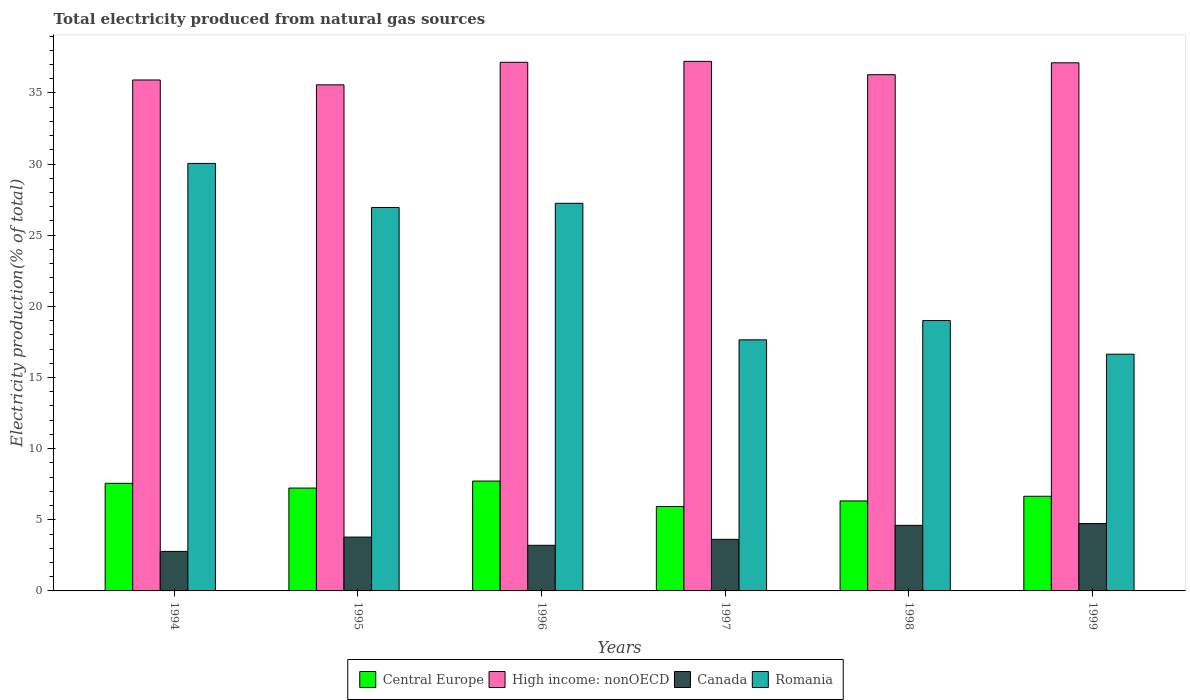How many groups of bars are there?
Keep it short and to the point. 6. How many bars are there on the 3rd tick from the left?
Your response must be concise. 4. What is the label of the 3rd group of bars from the left?
Make the answer very short. 1996. In how many cases, is the number of bars for a given year not equal to the number of legend labels?
Ensure brevity in your answer.  0. What is the total electricity produced in Romania in 1995?
Make the answer very short. 26.95. Across all years, what is the maximum total electricity produced in Canada?
Your response must be concise. 4.73. Across all years, what is the minimum total electricity produced in Romania?
Ensure brevity in your answer.  16.64. In which year was the total electricity produced in Romania maximum?
Your answer should be very brief. 1994. What is the total total electricity produced in Central Europe in the graph?
Ensure brevity in your answer.  41.42. What is the difference between the total electricity produced in Canada in 1998 and that in 1999?
Your response must be concise. -0.13. What is the difference between the total electricity produced in Central Europe in 1996 and the total electricity produced in Canada in 1999?
Your response must be concise. 2.99. What is the average total electricity produced in High income: nonOECD per year?
Offer a very short reply. 36.54. In the year 1994, what is the difference between the total electricity produced in High income: nonOECD and total electricity produced in Canada?
Your response must be concise. 33.13. What is the ratio of the total electricity produced in Canada in 1995 to that in 1999?
Your answer should be very brief. 0.8. Is the difference between the total electricity produced in High income: nonOECD in 1994 and 1998 greater than the difference between the total electricity produced in Canada in 1994 and 1998?
Your answer should be compact. Yes. What is the difference between the highest and the second highest total electricity produced in Central Europe?
Make the answer very short. 0.16. What is the difference between the highest and the lowest total electricity produced in Romania?
Keep it short and to the point. 13.41. Is the sum of the total electricity produced in Canada in 1996 and 1997 greater than the maximum total electricity produced in Romania across all years?
Offer a very short reply. No. What does the 1st bar from the left in 1995 represents?
Ensure brevity in your answer.  Central Europe. What does the 3rd bar from the right in 1996 represents?
Your answer should be compact. High income: nonOECD. How many bars are there?
Your answer should be compact. 24. Are all the bars in the graph horizontal?
Offer a very short reply. No. What is the difference between two consecutive major ticks on the Y-axis?
Provide a succinct answer. 5. How many legend labels are there?
Provide a succinct answer. 4. How are the legend labels stacked?
Your answer should be very brief. Horizontal. What is the title of the graph?
Provide a succinct answer. Total electricity produced from natural gas sources. Does "Morocco" appear as one of the legend labels in the graph?
Offer a very short reply. No. What is the Electricity production(% of total) in Central Europe in 1994?
Ensure brevity in your answer.  7.56. What is the Electricity production(% of total) of High income: nonOECD in 1994?
Ensure brevity in your answer.  35.91. What is the Electricity production(% of total) of Canada in 1994?
Offer a terse response. 2.78. What is the Electricity production(% of total) of Romania in 1994?
Make the answer very short. 30.05. What is the Electricity production(% of total) in Central Europe in 1995?
Keep it short and to the point. 7.23. What is the Electricity production(% of total) of High income: nonOECD in 1995?
Provide a succinct answer. 35.57. What is the Electricity production(% of total) in Canada in 1995?
Ensure brevity in your answer.  3.78. What is the Electricity production(% of total) of Romania in 1995?
Provide a succinct answer. 26.95. What is the Electricity production(% of total) of Central Europe in 1996?
Give a very brief answer. 7.72. What is the Electricity production(% of total) in High income: nonOECD in 1996?
Keep it short and to the point. 37.15. What is the Electricity production(% of total) in Canada in 1996?
Provide a succinct answer. 3.21. What is the Electricity production(% of total) of Romania in 1996?
Offer a terse response. 27.24. What is the Electricity production(% of total) in Central Europe in 1997?
Your answer should be very brief. 5.93. What is the Electricity production(% of total) in High income: nonOECD in 1997?
Your answer should be compact. 37.22. What is the Electricity production(% of total) in Canada in 1997?
Keep it short and to the point. 3.63. What is the Electricity production(% of total) in Romania in 1997?
Provide a succinct answer. 17.65. What is the Electricity production(% of total) of Central Europe in 1998?
Give a very brief answer. 6.32. What is the Electricity production(% of total) of High income: nonOECD in 1998?
Offer a very short reply. 36.28. What is the Electricity production(% of total) in Canada in 1998?
Provide a succinct answer. 4.61. What is the Electricity production(% of total) of Romania in 1998?
Provide a succinct answer. 19. What is the Electricity production(% of total) of Central Europe in 1999?
Your answer should be very brief. 6.65. What is the Electricity production(% of total) of High income: nonOECD in 1999?
Your response must be concise. 37.12. What is the Electricity production(% of total) of Canada in 1999?
Offer a terse response. 4.73. What is the Electricity production(% of total) in Romania in 1999?
Ensure brevity in your answer.  16.64. Across all years, what is the maximum Electricity production(% of total) of Central Europe?
Make the answer very short. 7.72. Across all years, what is the maximum Electricity production(% of total) in High income: nonOECD?
Offer a very short reply. 37.22. Across all years, what is the maximum Electricity production(% of total) of Canada?
Keep it short and to the point. 4.73. Across all years, what is the maximum Electricity production(% of total) in Romania?
Make the answer very short. 30.05. Across all years, what is the minimum Electricity production(% of total) of Central Europe?
Your answer should be compact. 5.93. Across all years, what is the minimum Electricity production(% of total) of High income: nonOECD?
Your response must be concise. 35.57. Across all years, what is the minimum Electricity production(% of total) of Canada?
Provide a succinct answer. 2.78. Across all years, what is the minimum Electricity production(% of total) of Romania?
Your answer should be very brief. 16.64. What is the total Electricity production(% of total) in Central Europe in the graph?
Provide a short and direct response. 41.42. What is the total Electricity production(% of total) of High income: nonOECD in the graph?
Ensure brevity in your answer.  219.25. What is the total Electricity production(% of total) in Canada in the graph?
Your response must be concise. 22.74. What is the total Electricity production(% of total) in Romania in the graph?
Make the answer very short. 137.52. What is the difference between the Electricity production(% of total) of Central Europe in 1994 and that in 1995?
Your answer should be very brief. 0.33. What is the difference between the Electricity production(% of total) of High income: nonOECD in 1994 and that in 1995?
Offer a very short reply. 0.34. What is the difference between the Electricity production(% of total) in Canada in 1994 and that in 1995?
Make the answer very short. -1.01. What is the difference between the Electricity production(% of total) in Romania in 1994 and that in 1995?
Ensure brevity in your answer.  3.1. What is the difference between the Electricity production(% of total) in Central Europe in 1994 and that in 1996?
Your response must be concise. -0.16. What is the difference between the Electricity production(% of total) in High income: nonOECD in 1994 and that in 1996?
Provide a succinct answer. -1.24. What is the difference between the Electricity production(% of total) of Canada in 1994 and that in 1996?
Offer a very short reply. -0.43. What is the difference between the Electricity production(% of total) of Romania in 1994 and that in 1996?
Make the answer very short. 2.8. What is the difference between the Electricity production(% of total) of Central Europe in 1994 and that in 1997?
Offer a terse response. 1.63. What is the difference between the Electricity production(% of total) in High income: nonOECD in 1994 and that in 1997?
Keep it short and to the point. -1.31. What is the difference between the Electricity production(% of total) in Canada in 1994 and that in 1997?
Make the answer very short. -0.85. What is the difference between the Electricity production(% of total) in Romania in 1994 and that in 1997?
Ensure brevity in your answer.  12.4. What is the difference between the Electricity production(% of total) of Central Europe in 1994 and that in 1998?
Ensure brevity in your answer.  1.24. What is the difference between the Electricity production(% of total) in High income: nonOECD in 1994 and that in 1998?
Provide a succinct answer. -0.37. What is the difference between the Electricity production(% of total) in Canada in 1994 and that in 1998?
Provide a succinct answer. -1.83. What is the difference between the Electricity production(% of total) in Romania in 1994 and that in 1998?
Provide a succinct answer. 11.04. What is the difference between the Electricity production(% of total) of Central Europe in 1994 and that in 1999?
Your answer should be very brief. 0.91. What is the difference between the Electricity production(% of total) of High income: nonOECD in 1994 and that in 1999?
Provide a short and direct response. -1.21. What is the difference between the Electricity production(% of total) of Canada in 1994 and that in 1999?
Keep it short and to the point. -1.96. What is the difference between the Electricity production(% of total) of Romania in 1994 and that in 1999?
Offer a very short reply. 13.41. What is the difference between the Electricity production(% of total) of Central Europe in 1995 and that in 1996?
Provide a short and direct response. -0.49. What is the difference between the Electricity production(% of total) of High income: nonOECD in 1995 and that in 1996?
Provide a short and direct response. -1.58. What is the difference between the Electricity production(% of total) of Canada in 1995 and that in 1996?
Your response must be concise. 0.58. What is the difference between the Electricity production(% of total) of Romania in 1995 and that in 1996?
Your answer should be very brief. -0.29. What is the difference between the Electricity production(% of total) in Central Europe in 1995 and that in 1997?
Provide a short and direct response. 1.29. What is the difference between the Electricity production(% of total) in High income: nonOECD in 1995 and that in 1997?
Your answer should be compact. -1.65. What is the difference between the Electricity production(% of total) of Canada in 1995 and that in 1997?
Ensure brevity in your answer.  0.16. What is the difference between the Electricity production(% of total) in Romania in 1995 and that in 1997?
Keep it short and to the point. 9.3. What is the difference between the Electricity production(% of total) in Central Europe in 1995 and that in 1998?
Your answer should be very brief. 0.91. What is the difference between the Electricity production(% of total) in High income: nonOECD in 1995 and that in 1998?
Ensure brevity in your answer.  -0.71. What is the difference between the Electricity production(% of total) of Canada in 1995 and that in 1998?
Ensure brevity in your answer.  -0.83. What is the difference between the Electricity production(% of total) of Romania in 1995 and that in 1998?
Give a very brief answer. 7.95. What is the difference between the Electricity production(% of total) of Central Europe in 1995 and that in 1999?
Offer a terse response. 0.58. What is the difference between the Electricity production(% of total) of High income: nonOECD in 1995 and that in 1999?
Your response must be concise. -1.55. What is the difference between the Electricity production(% of total) in Canada in 1995 and that in 1999?
Ensure brevity in your answer.  -0.95. What is the difference between the Electricity production(% of total) in Romania in 1995 and that in 1999?
Your response must be concise. 10.31. What is the difference between the Electricity production(% of total) of Central Europe in 1996 and that in 1997?
Make the answer very short. 1.79. What is the difference between the Electricity production(% of total) of High income: nonOECD in 1996 and that in 1997?
Offer a very short reply. -0.07. What is the difference between the Electricity production(% of total) of Canada in 1996 and that in 1997?
Provide a short and direct response. -0.42. What is the difference between the Electricity production(% of total) in Romania in 1996 and that in 1997?
Keep it short and to the point. 9.6. What is the difference between the Electricity production(% of total) of Central Europe in 1996 and that in 1998?
Ensure brevity in your answer.  1.4. What is the difference between the Electricity production(% of total) of High income: nonOECD in 1996 and that in 1998?
Offer a very short reply. 0.87. What is the difference between the Electricity production(% of total) of Canada in 1996 and that in 1998?
Provide a short and direct response. -1.4. What is the difference between the Electricity production(% of total) in Romania in 1996 and that in 1998?
Offer a terse response. 8.24. What is the difference between the Electricity production(% of total) of Central Europe in 1996 and that in 1999?
Make the answer very short. 1.07. What is the difference between the Electricity production(% of total) in High income: nonOECD in 1996 and that in 1999?
Offer a terse response. 0.04. What is the difference between the Electricity production(% of total) of Canada in 1996 and that in 1999?
Provide a short and direct response. -1.53. What is the difference between the Electricity production(% of total) of Romania in 1996 and that in 1999?
Give a very brief answer. 10.6. What is the difference between the Electricity production(% of total) in Central Europe in 1997 and that in 1998?
Keep it short and to the point. -0.39. What is the difference between the Electricity production(% of total) in High income: nonOECD in 1997 and that in 1998?
Offer a terse response. 0.94. What is the difference between the Electricity production(% of total) of Canada in 1997 and that in 1998?
Provide a succinct answer. -0.98. What is the difference between the Electricity production(% of total) of Romania in 1997 and that in 1998?
Your answer should be very brief. -1.36. What is the difference between the Electricity production(% of total) in Central Europe in 1997 and that in 1999?
Provide a succinct answer. -0.72. What is the difference between the Electricity production(% of total) of High income: nonOECD in 1997 and that in 1999?
Your answer should be very brief. 0.1. What is the difference between the Electricity production(% of total) in Canada in 1997 and that in 1999?
Provide a succinct answer. -1.11. What is the difference between the Electricity production(% of total) of Romania in 1997 and that in 1999?
Offer a very short reply. 1.01. What is the difference between the Electricity production(% of total) in Central Europe in 1998 and that in 1999?
Provide a succinct answer. -0.33. What is the difference between the Electricity production(% of total) of High income: nonOECD in 1998 and that in 1999?
Your response must be concise. -0.83. What is the difference between the Electricity production(% of total) in Canada in 1998 and that in 1999?
Your response must be concise. -0.12. What is the difference between the Electricity production(% of total) in Romania in 1998 and that in 1999?
Ensure brevity in your answer.  2.36. What is the difference between the Electricity production(% of total) in Central Europe in 1994 and the Electricity production(% of total) in High income: nonOECD in 1995?
Give a very brief answer. -28.01. What is the difference between the Electricity production(% of total) of Central Europe in 1994 and the Electricity production(% of total) of Canada in 1995?
Keep it short and to the point. 3.78. What is the difference between the Electricity production(% of total) of Central Europe in 1994 and the Electricity production(% of total) of Romania in 1995?
Your answer should be very brief. -19.39. What is the difference between the Electricity production(% of total) in High income: nonOECD in 1994 and the Electricity production(% of total) in Canada in 1995?
Make the answer very short. 32.13. What is the difference between the Electricity production(% of total) of High income: nonOECD in 1994 and the Electricity production(% of total) of Romania in 1995?
Give a very brief answer. 8.96. What is the difference between the Electricity production(% of total) in Canada in 1994 and the Electricity production(% of total) in Romania in 1995?
Your answer should be compact. -24.17. What is the difference between the Electricity production(% of total) in Central Europe in 1994 and the Electricity production(% of total) in High income: nonOECD in 1996?
Keep it short and to the point. -29.59. What is the difference between the Electricity production(% of total) in Central Europe in 1994 and the Electricity production(% of total) in Canada in 1996?
Provide a short and direct response. 4.36. What is the difference between the Electricity production(% of total) in Central Europe in 1994 and the Electricity production(% of total) in Romania in 1996?
Keep it short and to the point. -19.68. What is the difference between the Electricity production(% of total) in High income: nonOECD in 1994 and the Electricity production(% of total) in Canada in 1996?
Provide a short and direct response. 32.7. What is the difference between the Electricity production(% of total) in High income: nonOECD in 1994 and the Electricity production(% of total) in Romania in 1996?
Provide a succinct answer. 8.67. What is the difference between the Electricity production(% of total) of Canada in 1994 and the Electricity production(% of total) of Romania in 1996?
Provide a short and direct response. -24.46. What is the difference between the Electricity production(% of total) of Central Europe in 1994 and the Electricity production(% of total) of High income: nonOECD in 1997?
Keep it short and to the point. -29.66. What is the difference between the Electricity production(% of total) in Central Europe in 1994 and the Electricity production(% of total) in Canada in 1997?
Your answer should be very brief. 3.94. What is the difference between the Electricity production(% of total) of Central Europe in 1994 and the Electricity production(% of total) of Romania in 1997?
Your response must be concise. -10.08. What is the difference between the Electricity production(% of total) in High income: nonOECD in 1994 and the Electricity production(% of total) in Canada in 1997?
Make the answer very short. 32.28. What is the difference between the Electricity production(% of total) in High income: nonOECD in 1994 and the Electricity production(% of total) in Romania in 1997?
Offer a very short reply. 18.26. What is the difference between the Electricity production(% of total) of Canada in 1994 and the Electricity production(% of total) of Romania in 1997?
Ensure brevity in your answer.  -14.87. What is the difference between the Electricity production(% of total) of Central Europe in 1994 and the Electricity production(% of total) of High income: nonOECD in 1998?
Your response must be concise. -28.72. What is the difference between the Electricity production(% of total) of Central Europe in 1994 and the Electricity production(% of total) of Canada in 1998?
Keep it short and to the point. 2.95. What is the difference between the Electricity production(% of total) in Central Europe in 1994 and the Electricity production(% of total) in Romania in 1998?
Your answer should be compact. -11.44. What is the difference between the Electricity production(% of total) of High income: nonOECD in 1994 and the Electricity production(% of total) of Canada in 1998?
Provide a succinct answer. 31.3. What is the difference between the Electricity production(% of total) in High income: nonOECD in 1994 and the Electricity production(% of total) in Romania in 1998?
Your answer should be very brief. 16.91. What is the difference between the Electricity production(% of total) of Canada in 1994 and the Electricity production(% of total) of Romania in 1998?
Your answer should be compact. -16.22. What is the difference between the Electricity production(% of total) in Central Europe in 1994 and the Electricity production(% of total) in High income: nonOECD in 1999?
Your response must be concise. -29.55. What is the difference between the Electricity production(% of total) in Central Europe in 1994 and the Electricity production(% of total) in Canada in 1999?
Offer a very short reply. 2.83. What is the difference between the Electricity production(% of total) of Central Europe in 1994 and the Electricity production(% of total) of Romania in 1999?
Offer a terse response. -9.08. What is the difference between the Electricity production(% of total) of High income: nonOECD in 1994 and the Electricity production(% of total) of Canada in 1999?
Provide a succinct answer. 31.18. What is the difference between the Electricity production(% of total) of High income: nonOECD in 1994 and the Electricity production(% of total) of Romania in 1999?
Give a very brief answer. 19.27. What is the difference between the Electricity production(% of total) in Canada in 1994 and the Electricity production(% of total) in Romania in 1999?
Offer a terse response. -13.86. What is the difference between the Electricity production(% of total) in Central Europe in 1995 and the Electricity production(% of total) in High income: nonOECD in 1996?
Make the answer very short. -29.92. What is the difference between the Electricity production(% of total) in Central Europe in 1995 and the Electricity production(% of total) in Canada in 1996?
Give a very brief answer. 4.02. What is the difference between the Electricity production(% of total) in Central Europe in 1995 and the Electricity production(% of total) in Romania in 1996?
Your answer should be compact. -20.01. What is the difference between the Electricity production(% of total) in High income: nonOECD in 1995 and the Electricity production(% of total) in Canada in 1996?
Provide a succinct answer. 32.36. What is the difference between the Electricity production(% of total) of High income: nonOECD in 1995 and the Electricity production(% of total) of Romania in 1996?
Provide a succinct answer. 8.33. What is the difference between the Electricity production(% of total) of Canada in 1995 and the Electricity production(% of total) of Romania in 1996?
Your answer should be very brief. -23.46. What is the difference between the Electricity production(% of total) of Central Europe in 1995 and the Electricity production(% of total) of High income: nonOECD in 1997?
Provide a succinct answer. -29.99. What is the difference between the Electricity production(% of total) of Central Europe in 1995 and the Electricity production(% of total) of Canada in 1997?
Offer a terse response. 3.6. What is the difference between the Electricity production(% of total) of Central Europe in 1995 and the Electricity production(% of total) of Romania in 1997?
Provide a short and direct response. -10.42. What is the difference between the Electricity production(% of total) in High income: nonOECD in 1995 and the Electricity production(% of total) in Canada in 1997?
Give a very brief answer. 31.94. What is the difference between the Electricity production(% of total) of High income: nonOECD in 1995 and the Electricity production(% of total) of Romania in 1997?
Give a very brief answer. 17.92. What is the difference between the Electricity production(% of total) in Canada in 1995 and the Electricity production(% of total) in Romania in 1997?
Provide a short and direct response. -13.86. What is the difference between the Electricity production(% of total) in Central Europe in 1995 and the Electricity production(% of total) in High income: nonOECD in 1998?
Offer a terse response. -29.05. What is the difference between the Electricity production(% of total) of Central Europe in 1995 and the Electricity production(% of total) of Canada in 1998?
Your answer should be compact. 2.62. What is the difference between the Electricity production(% of total) in Central Europe in 1995 and the Electricity production(% of total) in Romania in 1998?
Your response must be concise. -11.77. What is the difference between the Electricity production(% of total) in High income: nonOECD in 1995 and the Electricity production(% of total) in Canada in 1998?
Your answer should be compact. 30.96. What is the difference between the Electricity production(% of total) of High income: nonOECD in 1995 and the Electricity production(% of total) of Romania in 1998?
Provide a short and direct response. 16.57. What is the difference between the Electricity production(% of total) of Canada in 1995 and the Electricity production(% of total) of Romania in 1998?
Your answer should be compact. -15.22. What is the difference between the Electricity production(% of total) in Central Europe in 1995 and the Electricity production(% of total) in High income: nonOECD in 1999?
Make the answer very short. -29.89. What is the difference between the Electricity production(% of total) of Central Europe in 1995 and the Electricity production(% of total) of Canada in 1999?
Keep it short and to the point. 2.49. What is the difference between the Electricity production(% of total) of Central Europe in 1995 and the Electricity production(% of total) of Romania in 1999?
Provide a short and direct response. -9.41. What is the difference between the Electricity production(% of total) in High income: nonOECD in 1995 and the Electricity production(% of total) in Canada in 1999?
Your response must be concise. 30.83. What is the difference between the Electricity production(% of total) in High income: nonOECD in 1995 and the Electricity production(% of total) in Romania in 1999?
Ensure brevity in your answer.  18.93. What is the difference between the Electricity production(% of total) in Canada in 1995 and the Electricity production(% of total) in Romania in 1999?
Offer a terse response. -12.85. What is the difference between the Electricity production(% of total) in Central Europe in 1996 and the Electricity production(% of total) in High income: nonOECD in 1997?
Make the answer very short. -29.5. What is the difference between the Electricity production(% of total) of Central Europe in 1996 and the Electricity production(% of total) of Canada in 1997?
Offer a terse response. 4.09. What is the difference between the Electricity production(% of total) in Central Europe in 1996 and the Electricity production(% of total) in Romania in 1997?
Offer a terse response. -9.92. What is the difference between the Electricity production(% of total) of High income: nonOECD in 1996 and the Electricity production(% of total) of Canada in 1997?
Your answer should be compact. 33.53. What is the difference between the Electricity production(% of total) of High income: nonOECD in 1996 and the Electricity production(% of total) of Romania in 1997?
Your answer should be very brief. 19.51. What is the difference between the Electricity production(% of total) in Canada in 1996 and the Electricity production(% of total) in Romania in 1997?
Give a very brief answer. -14.44. What is the difference between the Electricity production(% of total) of Central Europe in 1996 and the Electricity production(% of total) of High income: nonOECD in 1998?
Keep it short and to the point. -28.56. What is the difference between the Electricity production(% of total) in Central Europe in 1996 and the Electricity production(% of total) in Canada in 1998?
Provide a short and direct response. 3.11. What is the difference between the Electricity production(% of total) in Central Europe in 1996 and the Electricity production(% of total) in Romania in 1998?
Provide a short and direct response. -11.28. What is the difference between the Electricity production(% of total) in High income: nonOECD in 1996 and the Electricity production(% of total) in Canada in 1998?
Ensure brevity in your answer.  32.54. What is the difference between the Electricity production(% of total) of High income: nonOECD in 1996 and the Electricity production(% of total) of Romania in 1998?
Keep it short and to the point. 18.15. What is the difference between the Electricity production(% of total) of Canada in 1996 and the Electricity production(% of total) of Romania in 1998?
Your response must be concise. -15.8. What is the difference between the Electricity production(% of total) of Central Europe in 1996 and the Electricity production(% of total) of High income: nonOECD in 1999?
Give a very brief answer. -29.4. What is the difference between the Electricity production(% of total) of Central Europe in 1996 and the Electricity production(% of total) of Canada in 1999?
Make the answer very short. 2.99. What is the difference between the Electricity production(% of total) in Central Europe in 1996 and the Electricity production(% of total) in Romania in 1999?
Your answer should be compact. -8.92. What is the difference between the Electricity production(% of total) of High income: nonOECD in 1996 and the Electricity production(% of total) of Canada in 1999?
Provide a succinct answer. 32.42. What is the difference between the Electricity production(% of total) of High income: nonOECD in 1996 and the Electricity production(% of total) of Romania in 1999?
Offer a very short reply. 20.52. What is the difference between the Electricity production(% of total) of Canada in 1996 and the Electricity production(% of total) of Romania in 1999?
Keep it short and to the point. -13.43. What is the difference between the Electricity production(% of total) in Central Europe in 1997 and the Electricity production(% of total) in High income: nonOECD in 1998?
Your response must be concise. -30.35. What is the difference between the Electricity production(% of total) in Central Europe in 1997 and the Electricity production(% of total) in Canada in 1998?
Give a very brief answer. 1.33. What is the difference between the Electricity production(% of total) in Central Europe in 1997 and the Electricity production(% of total) in Romania in 1998?
Ensure brevity in your answer.  -13.07. What is the difference between the Electricity production(% of total) in High income: nonOECD in 1997 and the Electricity production(% of total) in Canada in 1998?
Provide a short and direct response. 32.61. What is the difference between the Electricity production(% of total) of High income: nonOECD in 1997 and the Electricity production(% of total) of Romania in 1998?
Give a very brief answer. 18.22. What is the difference between the Electricity production(% of total) in Canada in 1997 and the Electricity production(% of total) in Romania in 1998?
Offer a very short reply. -15.37. What is the difference between the Electricity production(% of total) in Central Europe in 1997 and the Electricity production(% of total) in High income: nonOECD in 1999?
Ensure brevity in your answer.  -31.18. What is the difference between the Electricity production(% of total) of Central Europe in 1997 and the Electricity production(% of total) of Canada in 1999?
Your answer should be compact. 1.2. What is the difference between the Electricity production(% of total) in Central Europe in 1997 and the Electricity production(% of total) in Romania in 1999?
Offer a terse response. -10.7. What is the difference between the Electricity production(% of total) of High income: nonOECD in 1997 and the Electricity production(% of total) of Canada in 1999?
Provide a short and direct response. 32.48. What is the difference between the Electricity production(% of total) of High income: nonOECD in 1997 and the Electricity production(% of total) of Romania in 1999?
Offer a very short reply. 20.58. What is the difference between the Electricity production(% of total) of Canada in 1997 and the Electricity production(% of total) of Romania in 1999?
Provide a short and direct response. -13.01. What is the difference between the Electricity production(% of total) of Central Europe in 1998 and the Electricity production(% of total) of High income: nonOECD in 1999?
Your answer should be compact. -30.79. What is the difference between the Electricity production(% of total) of Central Europe in 1998 and the Electricity production(% of total) of Canada in 1999?
Make the answer very short. 1.59. What is the difference between the Electricity production(% of total) of Central Europe in 1998 and the Electricity production(% of total) of Romania in 1999?
Offer a very short reply. -10.31. What is the difference between the Electricity production(% of total) of High income: nonOECD in 1998 and the Electricity production(% of total) of Canada in 1999?
Your answer should be compact. 31.55. What is the difference between the Electricity production(% of total) in High income: nonOECD in 1998 and the Electricity production(% of total) in Romania in 1999?
Your answer should be compact. 19.64. What is the difference between the Electricity production(% of total) in Canada in 1998 and the Electricity production(% of total) in Romania in 1999?
Your answer should be very brief. -12.03. What is the average Electricity production(% of total) in Central Europe per year?
Offer a very short reply. 6.9. What is the average Electricity production(% of total) in High income: nonOECD per year?
Provide a short and direct response. 36.54. What is the average Electricity production(% of total) of Canada per year?
Provide a short and direct response. 3.79. What is the average Electricity production(% of total) of Romania per year?
Provide a short and direct response. 22.92. In the year 1994, what is the difference between the Electricity production(% of total) of Central Europe and Electricity production(% of total) of High income: nonOECD?
Make the answer very short. -28.35. In the year 1994, what is the difference between the Electricity production(% of total) in Central Europe and Electricity production(% of total) in Canada?
Provide a succinct answer. 4.78. In the year 1994, what is the difference between the Electricity production(% of total) in Central Europe and Electricity production(% of total) in Romania?
Give a very brief answer. -22.48. In the year 1994, what is the difference between the Electricity production(% of total) in High income: nonOECD and Electricity production(% of total) in Canada?
Ensure brevity in your answer.  33.13. In the year 1994, what is the difference between the Electricity production(% of total) in High income: nonOECD and Electricity production(% of total) in Romania?
Make the answer very short. 5.86. In the year 1994, what is the difference between the Electricity production(% of total) of Canada and Electricity production(% of total) of Romania?
Keep it short and to the point. -27.27. In the year 1995, what is the difference between the Electricity production(% of total) of Central Europe and Electricity production(% of total) of High income: nonOECD?
Offer a terse response. -28.34. In the year 1995, what is the difference between the Electricity production(% of total) of Central Europe and Electricity production(% of total) of Canada?
Ensure brevity in your answer.  3.44. In the year 1995, what is the difference between the Electricity production(% of total) in Central Europe and Electricity production(% of total) in Romania?
Give a very brief answer. -19.72. In the year 1995, what is the difference between the Electricity production(% of total) in High income: nonOECD and Electricity production(% of total) in Canada?
Offer a terse response. 31.78. In the year 1995, what is the difference between the Electricity production(% of total) of High income: nonOECD and Electricity production(% of total) of Romania?
Give a very brief answer. 8.62. In the year 1995, what is the difference between the Electricity production(% of total) of Canada and Electricity production(% of total) of Romania?
Ensure brevity in your answer.  -23.16. In the year 1996, what is the difference between the Electricity production(% of total) in Central Europe and Electricity production(% of total) in High income: nonOECD?
Offer a very short reply. -29.43. In the year 1996, what is the difference between the Electricity production(% of total) in Central Europe and Electricity production(% of total) in Canada?
Provide a short and direct response. 4.52. In the year 1996, what is the difference between the Electricity production(% of total) of Central Europe and Electricity production(% of total) of Romania?
Offer a very short reply. -19.52. In the year 1996, what is the difference between the Electricity production(% of total) of High income: nonOECD and Electricity production(% of total) of Canada?
Your response must be concise. 33.95. In the year 1996, what is the difference between the Electricity production(% of total) of High income: nonOECD and Electricity production(% of total) of Romania?
Ensure brevity in your answer.  9.91. In the year 1996, what is the difference between the Electricity production(% of total) in Canada and Electricity production(% of total) in Romania?
Give a very brief answer. -24.04. In the year 1997, what is the difference between the Electricity production(% of total) of Central Europe and Electricity production(% of total) of High income: nonOECD?
Provide a short and direct response. -31.28. In the year 1997, what is the difference between the Electricity production(% of total) of Central Europe and Electricity production(% of total) of Canada?
Give a very brief answer. 2.31. In the year 1997, what is the difference between the Electricity production(% of total) in Central Europe and Electricity production(% of total) in Romania?
Offer a very short reply. -11.71. In the year 1997, what is the difference between the Electricity production(% of total) in High income: nonOECD and Electricity production(% of total) in Canada?
Make the answer very short. 33.59. In the year 1997, what is the difference between the Electricity production(% of total) in High income: nonOECD and Electricity production(% of total) in Romania?
Your response must be concise. 19.57. In the year 1997, what is the difference between the Electricity production(% of total) in Canada and Electricity production(% of total) in Romania?
Keep it short and to the point. -14.02. In the year 1998, what is the difference between the Electricity production(% of total) in Central Europe and Electricity production(% of total) in High income: nonOECD?
Provide a short and direct response. -29.96. In the year 1998, what is the difference between the Electricity production(% of total) in Central Europe and Electricity production(% of total) in Canada?
Give a very brief answer. 1.71. In the year 1998, what is the difference between the Electricity production(% of total) in Central Europe and Electricity production(% of total) in Romania?
Provide a short and direct response. -12.68. In the year 1998, what is the difference between the Electricity production(% of total) in High income: nonOECD and Electricity production(% of total) in Canada?
Keep it short and to the point. 31.67. In the year 1998, what is the difference between the Electricity production(% of total) of High income: nonOECD and Electricity production(% of total) of Romania?
Your response must be concise. 17.28. In the year 1998, what is the difference between the Electricity production(% of total) of Canada and Electricity production(% of total) of Romania?
Make the answer very short. -14.39. In the year 1999, what is the difference between the Electricity production(% of total) of Central Europe and Electricity production(% of total) of High income: nonOECD?
Give a very brief answer. -30.46. In the year 1999, what is the difference between the Electricity production(% of total) in Central Europe and Electricity production(% of total) in Canada?
Keep it short and to the point. 1.92. In the year 1999, what is the difference between the Electricity production(% of total) in Central Europe and Electricity production(% of total) in Romania?
Provide a short and direct response. -9.99. In the year 1999, what is the difference between the Electricity production(% of total) in High income: nonOECD and Electricity production(% of total) in Canada?
Offer a terse response. 32.38. In the year 1999, what is the difference between the Electricity production(% of total) of High income: nonOECD and Electricity production(% of total) of Romania?
Provide a short and direct response. 20.48. In the year 1999, what is the difference between the Electricity production(% of total) of Canada and Electricity production(% of total) of Romania?
Provide a short and direct response. -11.9. What is the ratio of the Electricity production(% of total) in Central Europe in 1994 to that in 1995?
Provide a succinct answer. 1.05. What is the ratio of the Electricity production(% of total) of High income: nonOECD in 1994 to that in 1995?
Offer a terse response. 1.01. What is the ratio of the Electricity production(% of total) in Canada in 1994 to that in 1995?
Your answer should be very brief. 0.73. What is the ratio of the Electricity production(% of total) of Romania in 1994 to that in 1995?
Your response must be concise. 1.11. What is the ratio of the Electricity production(% of total) in Central Europe in 1994 to that in 1996?
Your response must be concise. 0.98. What is the ratio of the Electricity production(% of total) in High income: nonOECD in 1994 to that in 1996?
Keep it short and to the point. 0.97. What is the ratio of the Electricity production(% of total) in Canada in 1994 to that in 1996?
Offer a terse response. 0.87. What is the ratio of the Electricity production(% of total) of Romania in 1994 to that in 1996?
Offer a terse response. 1.1. What is the ratio of the Electricity production(% of total) in Central Europe in 1994 to that in 1997?
Give a very brief answer. 1.27. What is the ratio of the Electricity production(% of total) of High income: nonOECD in 1994 to that in 1997?
Your answer should be compact. 0.96. What is the ratio of the Electricity production(% of total) in Canada in 1994 to that in 1997?
Keep it short and to the point. 0.77. What is the ratio of the Electricity production(% of total) of Romania in 1994 to that in 1997?
Make the answer very short. 1.7. What is the ratio of the Electricity production(% of total) in Central Europe in 1994 to that in 1998?
Your response must be concise. 1.2. What is the ratio of the Electricity production(% of total) in High income: nonOECD in 1994 to that in 1998?
Keep it short and to the point. 0.99. What is the ratio of the Electricity production(% of total) of Canada in 1994 to that in 1998?
Give a very brief answer. 0.6. What is the ratio of the Electricity production(% of total) of Romania in 1994 to that in 1998?
Provide a succinct answer. 1.58. What is the ratio of the Electricity production(% of total) in Central Europe in 1994 to that in 1999?
Your answer should be very brief. 1.14. What is the ratio of the Electricity production(% of total) in High income: nonOECD in 1994 to that in 1999?
Offer a very short reply. 0.97. What is the ratio of the Electricity production(% of total) in Canada in 1994 to that in 1999?
Provide a short and direct response. 0.59. What is the ratio of the Electricity production(% of total) in Romania in 1994 to that in 1999?
Offer a very short reply. 1.81. What is the ratio of the Electricity production(% of total) in Central Europe in 1995 to that in 1996?
Offer a very short reply. 0.94. What is the ratio of the Electricity production(% of total) of High income: nonOECD in 1995 to that in 1996?
Provide a short and direct response. 0.96. What is the ratio of the Electricity production(% of total) of Canada in 1995 to that in 1996?
Your answer should be very brief. 1.18. What is the ratio of the Electricity production(% of total) of Central Europe in 1995 to that in 1997?
Keep it short and to the point. 1.22. What is the ratio of the Electricity production(% of total) of High income: nonOECD in 1995 to that in 1997?
Keep it short and to the point. 0.96. What is the ratio of the Electricity production(% of total) in Canada in 1995 to that in 1997?
Give a very brief answer. 1.04. What is the ratio of the Electricity production(% of total) in Romania in 1995 to that in 1997?
Provide a short and direct response. 1.53. What is the ratio of the Electricity production(% of total) in Central Europe in 1995 to that in 1998?
Your response must be concise. 1.14. What is the ratio of the Electricity production(% of total) of High income: nonOECD in 1995 to that in 1998?
Keep it short and to the point. 0.98. What is the ratio of the Electricity production(% of total) in Canada in 1995 to that in 1998?
Provide a succinct answer. 0.82. What is the ratio of the Electricity production(% of total) in Romania in 1995 to that in 1998?
Provide a succinct answer. 1.42. What is the ratio of the Electricity production(% of total) in Central Europe in 1995 to that in 1999?
Offer a very short reply. 1.09. What is the ratio of the Electricity production(% of total) of Canada in 1995 to that in 1999?
Ensure brevity in your answer.  0.8. What is the ratio of the Electricity production(% of total) of Romania in 1995 to that in 1999?
Make the answer very short. 1.62. What is the ratio of the Electricity production(% of total) of Central Europe in 1996 to that in 1997?
Make the answer very short. 1.3. What is the ratio of the Electricity production(% of total) of High income: nonOECD in 1996 to that in 1997?
Your answer should be compact. 1. What is the ratio of the Electricity production(% of total) in Canada in 1996 to that in 1997?
Keep it short and to the point. 0.88. What is the ratio of the Electricity production(% of total) in Romania in 1996 to that in 1997?
Keep it short and to the point. 1.54. What is the ratio of the Electricity production(% of total) of Central Europe in 1996 to that in 1998?
Your answer should be compact. 1.22. What is the ratio of the Electricity production(% of total) in High income: nonOECD in 1996 to that in 1998?
Your response must be concise. 1.02. What is the ratio of the Electricity production(% of total) of Canada in 1996 to that in 1998?
Make the answer very short. 0.7. What is the ratio of the Electricity production(% of total) in Romania in 1996 to that in 1998?
Offer a very short reply. 1.43. What is the ratio of the Electricity production(% of total) in Central Europe in 1996 to that in 1999?
Keep it short and to the point. 1.16. What is the ratio of the Electricity production(% of total) in High income: nonOECD in 1996 to that in 1999?
Offer a terse response. 1. What is the ratio of the Electricity production(% of total) of Canada in 1996 to that in 1999?
Provide a succinct answer. 0.68. What is the ratio of the Electricity production(% of total) of Romania in 1996 to that in 1999?
Offer a terse response. 1.64. What is the ratio of the Electricity production(% of total) of Central Europe in 1997 to that in 1998?
Your response must be concise. 0.94. What is the ratio of the Electricity production(% of total) of High income: nonOECD in 1997 to that in 1998?
Offer a very short reply. 1.03. What is the ratio of the Electricity production(% of total) in Canada in 1997 to that in 1998?
Give a very brief answer. 0.79. What is the ratio of the Electricity production(% of total) of Romania in 1997 to that in 1998?
Make the answer very short. 0.93. What is the ratio of the Electricity production(% of total) in Central Europe in 1997 to that in 1999?
Offer a very short reply. 0.89. What is the ratio of the Electricity production(% of total) in Canada in 1997 to that in 1999?
Provide a succinct answer. 0.77. What is the ratio of the Electricity production(% of total) of Romania in 1997 to that in 1999?
Keep it short and to the point. 1.06. What is the ratio of the Electricity production(% of total) of Central Europe in 1998 to that in 1999?
Make the answer very short. 0.95. What is the ratio of the Electricity production(% of total) in High income: nonOECD in 1998 to that in 1999?
Offer a terse response. 0.98. What is the ratio of the Electricity production(% of total) of Canada in 1998 to that in 1999?
Your answer should be compact. 0.97. What is the ratio of the Electricity production(% of total) in Romania in 1998 to that in 1999?
Provide a short and direct response. 1.14. What is the difference between the highest and the second highest Electricity production(% of total) in Central Europe?
Give a very brief answer. 0.16. What is the difference between the highest and the second highest Electricity production(% of total) of High income: nonOECD?
Your response must be concise. 0.07. What is the difference between the highest and the second highest Electricity production(% of total) of Romania?
Keep it short and to the point. 2.8. What is the difference between the highest and the lowest Electricity production(% of total) in Central Europe?
Offer a terse response. 1.79. What is the difference between the highest and the lowest Electricity production(% of total) in High income: nonOECD?
Offer a terse response. 1.65. What is the difference between the highest and the lowest Electricity production(% of total) of Canada?
Ensure brevity in your answer.  1.96. What is the difference between the highest and the lowest Electricity production(% of total) in Romania?
Provide a succinct answer. 13.41. 